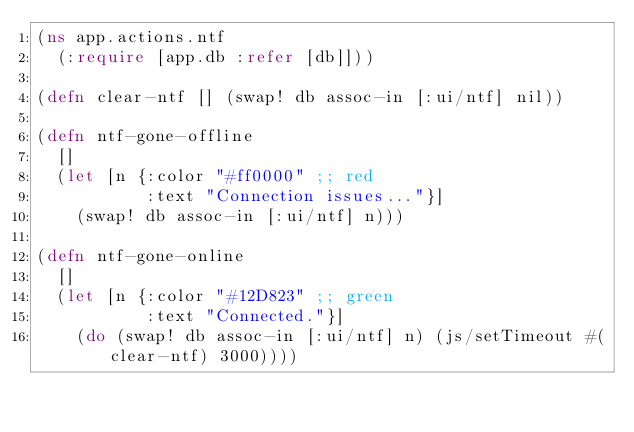Convert code to text. <code><loc_0><loc_0><loc_500><loc_500><_Clojure_>(ns app.actions.ntf
  (:require [app.db :refer [db]]))

(defn clear-ntf [] (swap! db assoc-in [:ui/ntf] nil))

(defn ntf-gone-offline
  []
  (let [n {:color "#ff0000" ;; red
           :text "Connection issues..."}]
    (swap! db assoc-in [:ui/ntf] n)))

(defn ntf-gone-online
  []
  (let [n {:color "#12D823" ;; green
           :text "Connected."}]
    (do (swap! db assoc-in [:ui/ntf] n) (js/setTimeout #(clear-ntf) 3000))))
</code> 